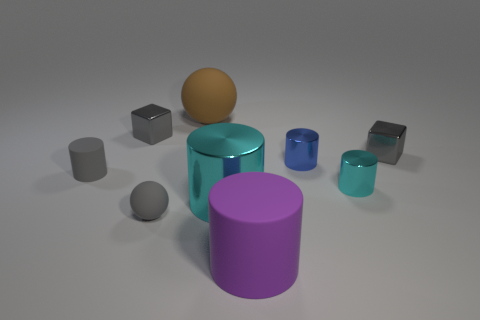How many gray cubes must be subtracted to get 1 gray cubes? 1 Subtract all big purple cylinders. How many cylinders are left? 4 Subtract 1 cylinders. How many cylinders are left? 4 Subtract all cyan cylinders. How many cylinders are left? 3 Subtract all cyan objects. Subtract all shiny cylinders. How many objects are left? 4 Add 2 large cyan things. How many large cyan things are left? 3 Add 8 big brown objects. How many big brown objects exist? 9 Subtract 0 purple blocks. How many objects are left? 9 Subtract all blocks. How many objects are left? 7 Subtract all gray cylinders. Subtract all purple cubes. How many cylinders are left? 4 